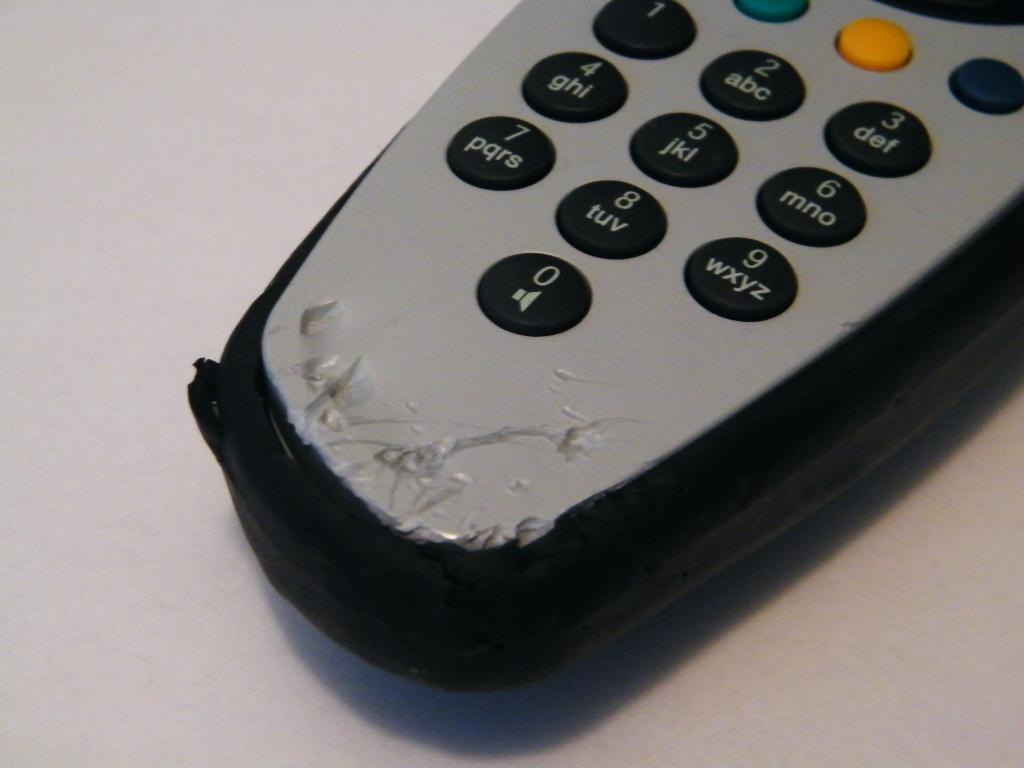<image>
Give a short and clear explanation of the subsequent image. A remote control has been chewed up just below the 0. 